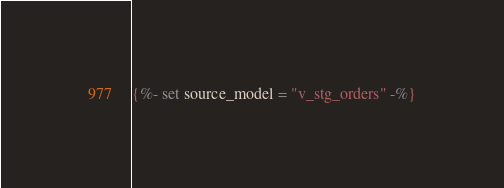<code> <loc_0><loc_0><loc_500><loc_500><_SQL_>{%- set source_model = "v_stg_orders" -%}</code> 